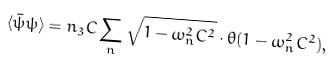Convert formula to latex. <formula><loc_0><loc_0><loc_500><loc_500>\langle \bar { \psi } \psi \rangle = n _ { 3 } C \sum _ { n } \sqrt { 1 - \omega _ { n } ^ { 2 } C ^ { 2 } } \cdot \theta ( 1 - \omega _ { n } ^ { 2 } C ^ { 2 } ) ,</formula> 